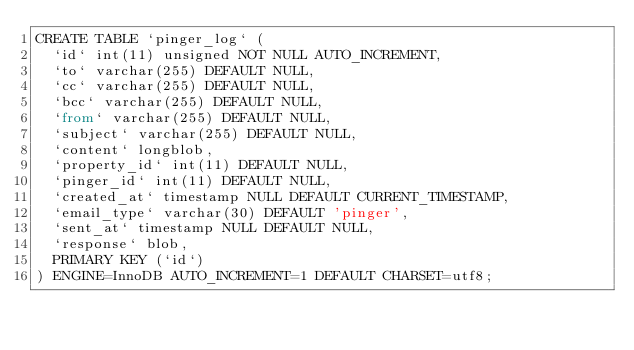<code> <loc_0><loc_0><loc_500><loc_500><_SQL_>CREATE TABLE `pinger_log` (
  `id` int(11) unsigned NOT NULL AUTO_INCREMENT,
  `to` varchar(255) DEFAULT NULL,
  `cc` varchar(255) DEFAULT NULL,
  `bcc` varchar(255) DEFAULT NULL,
  `from` varchar(255) DEFAULT NULL,
  `subject` varchar(255) DEFAULT NULL,
  `content` longblob,
  `property_id` int(11) DEFAULT NULL,
  `pinger_id` int(11) DEFAULT NULL,
  `created_at` timestamp NULL DEFAULT CURRENT_TIMESTAMP,
  `email_type` varchar(30) DEFAULT 'pinger',
  `sent_at` timestamp NULL DEFAULT NULL,
  `response` blob,
  PRIMARY KEY (`id`)
) ENGINE=InnoDB AUTO_INCREMENT=1 DEFAULT CHARSET=utf8;
</code> 